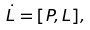Convert formula to latex. <formula><loc_0><loc_0><loc_500><loc_500>\dot { L } = [ P , L ] ,</formula> 